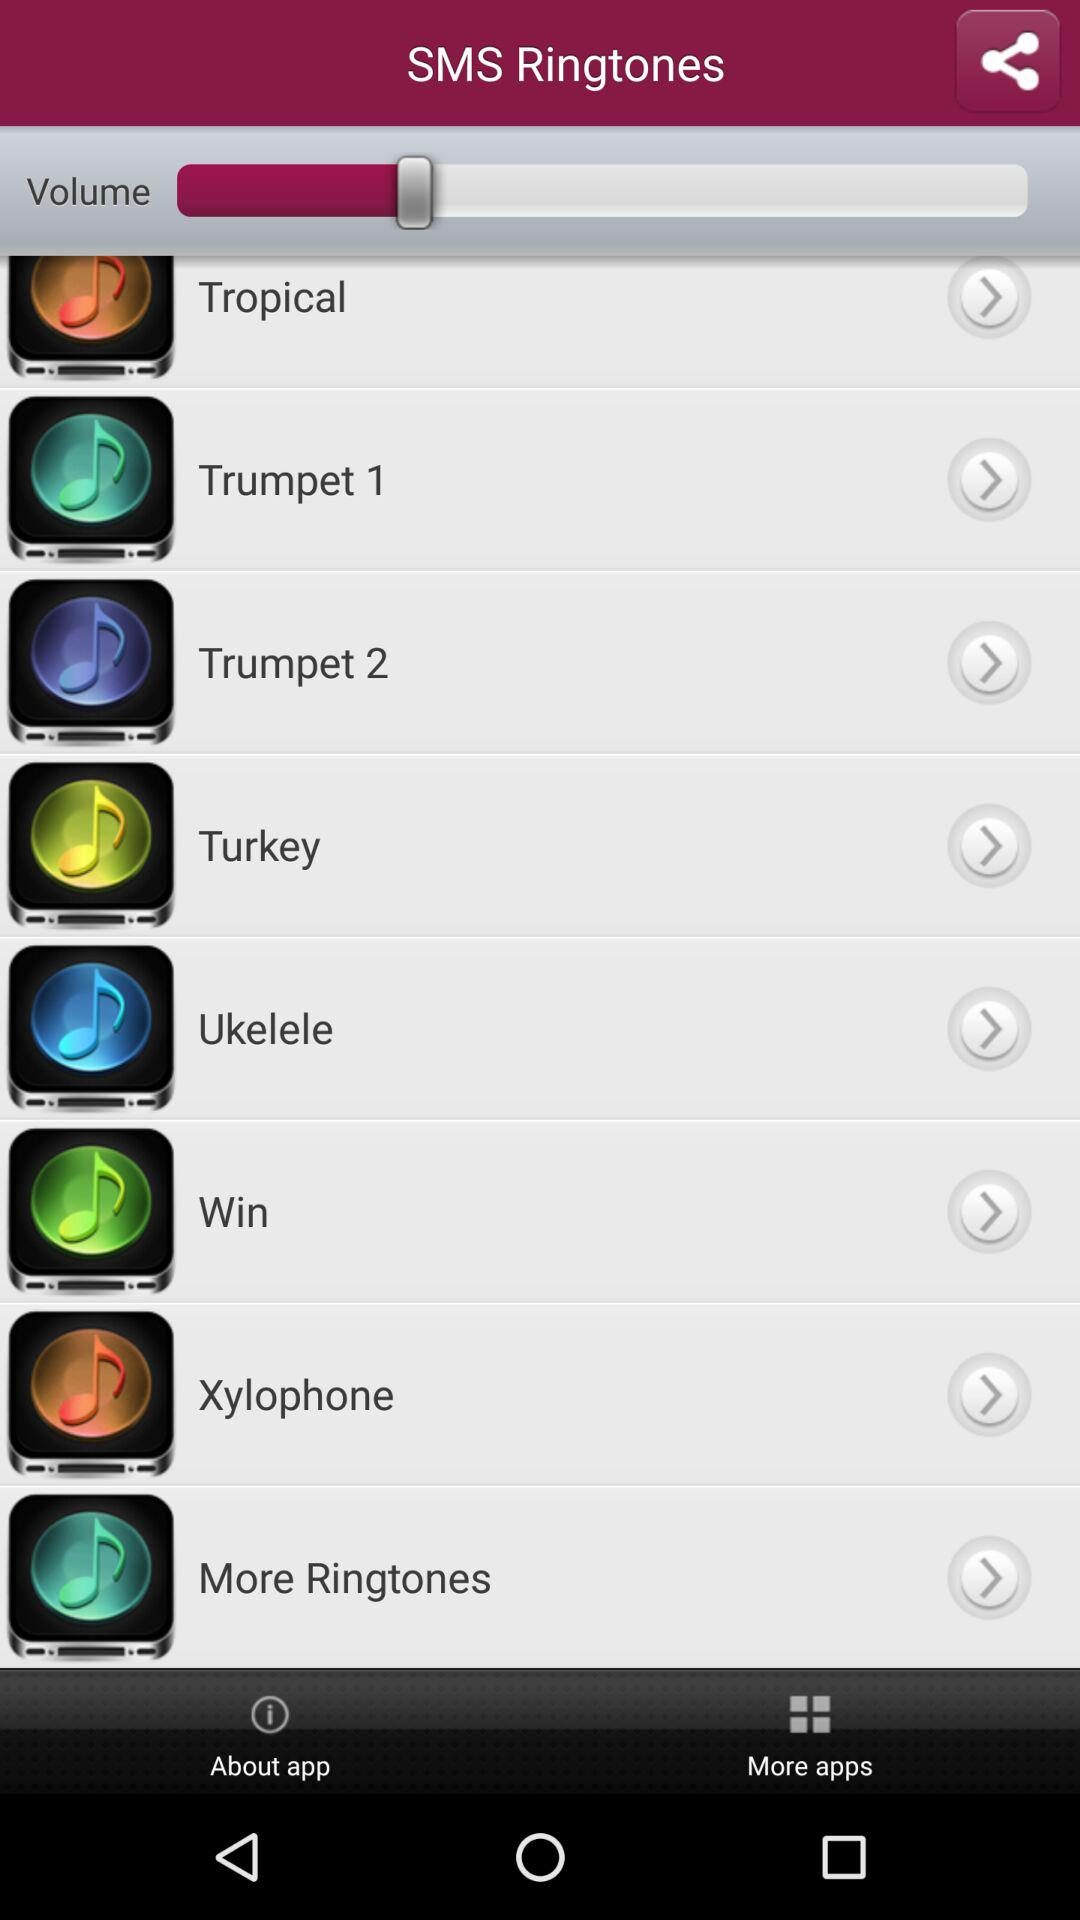How many ringtones are there in total?
Answer the question using a single word or phrase. 8 